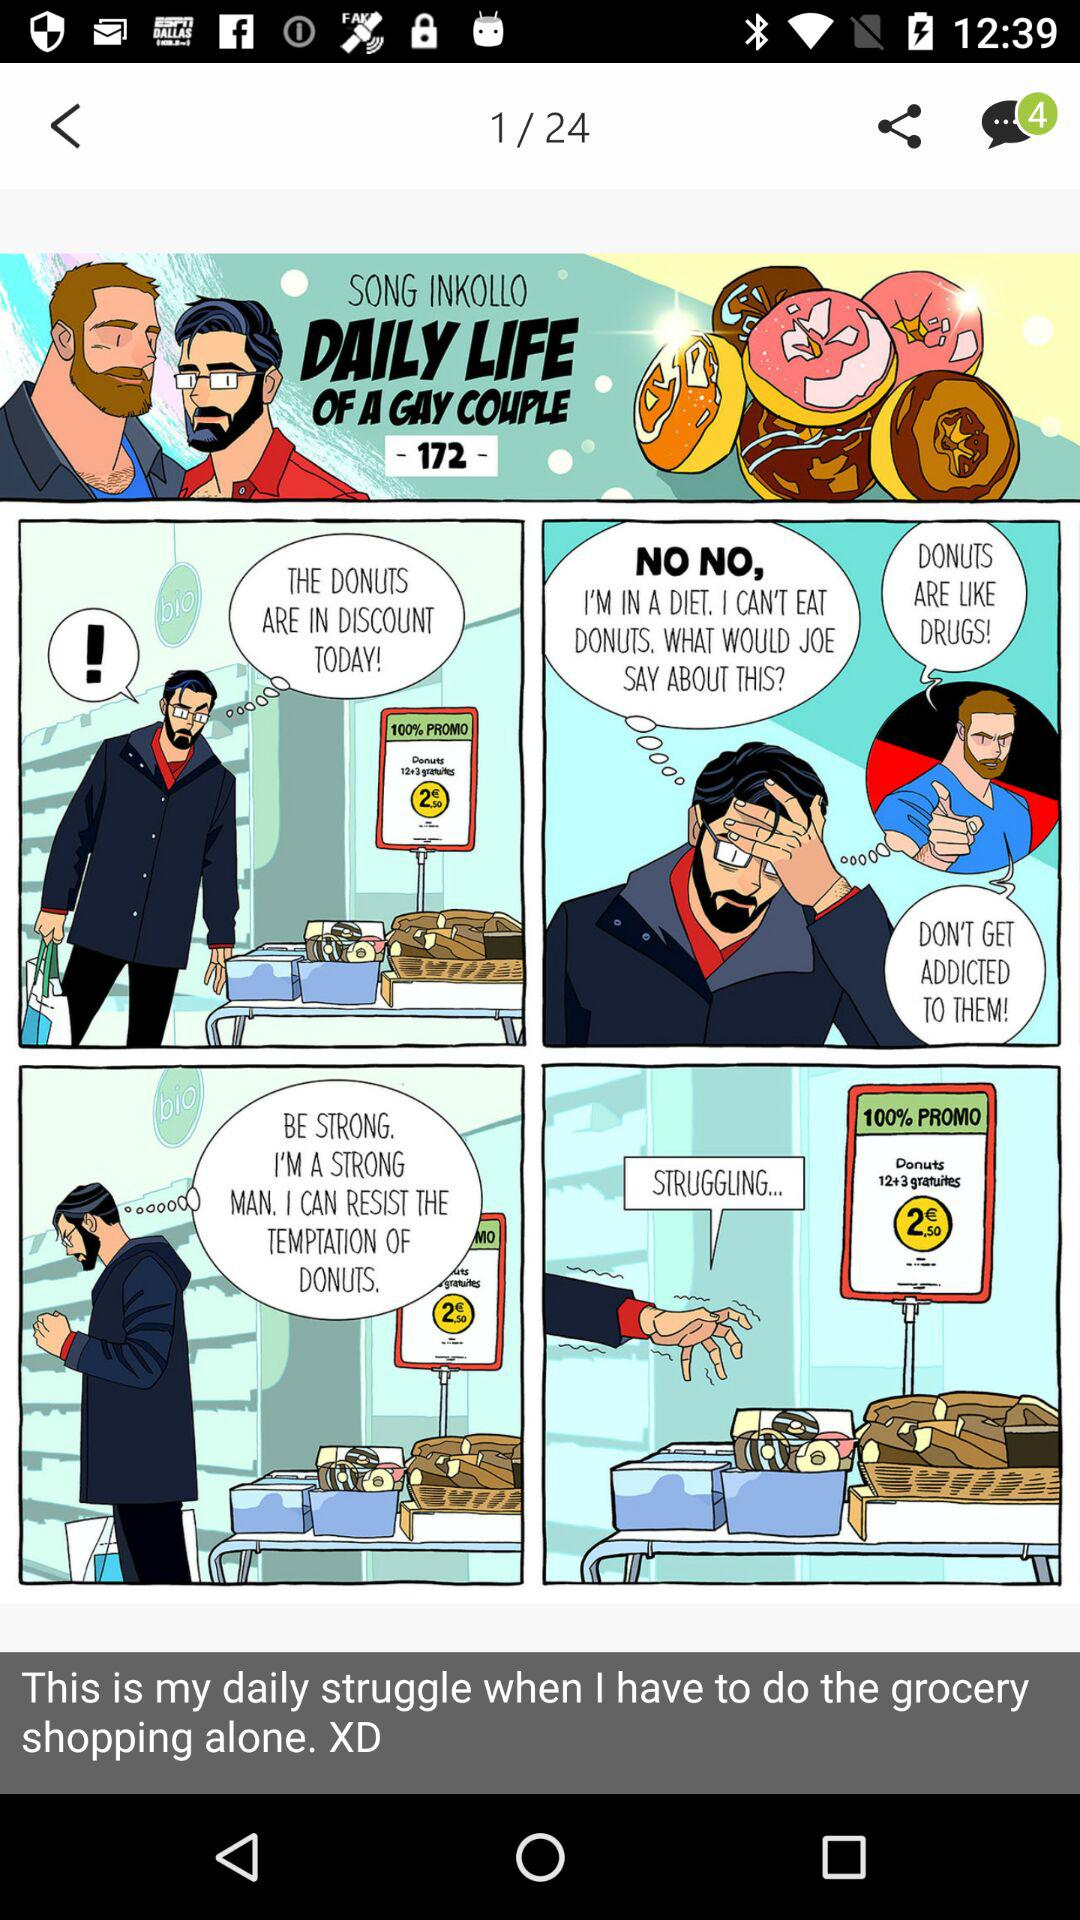How many unread chats are there? There are 4 unread chats. 